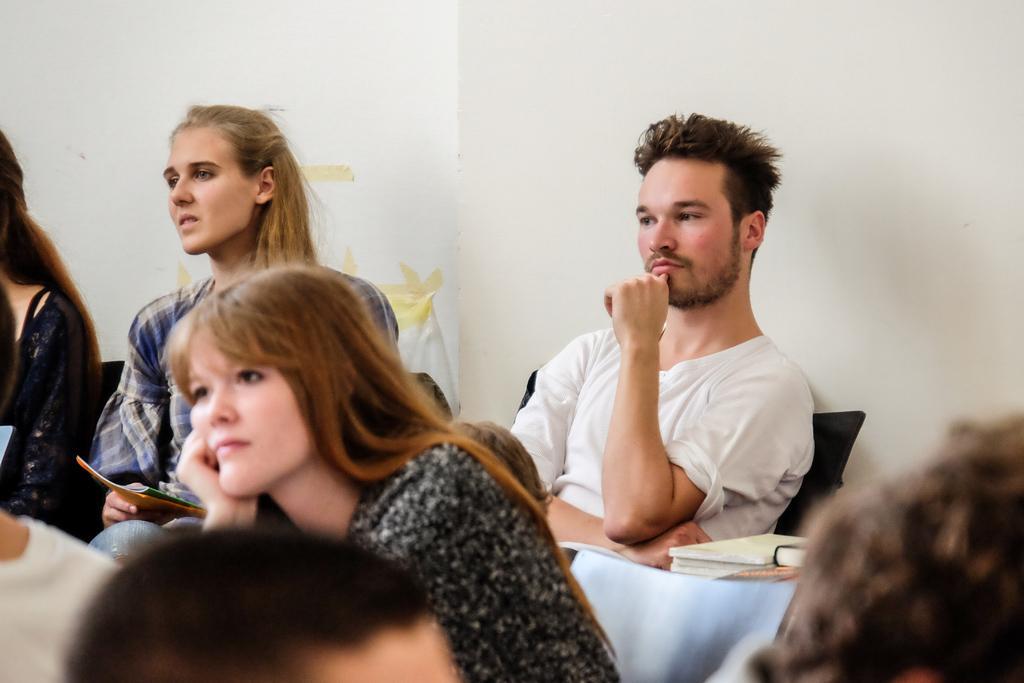How would you summarize this image in a sentence or two? This image is taken indoors. In the background there is a wall. In the middle of the image a few people are sitting on the chairs and there are a few books on the table. 